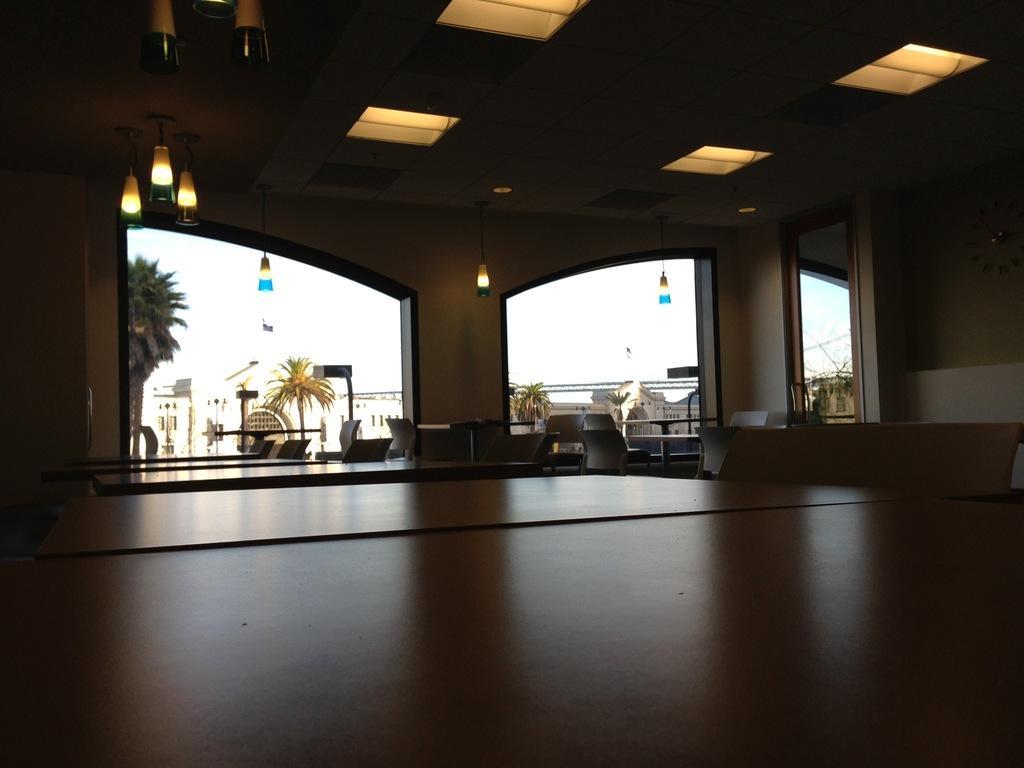Please provide a concise description of this image. The image is clicked inside a hall in which there are tables and chairs around it. At the top there is a ceiling with the lights. In the background there are buildings and trees in front of them. At the top there is sky. 